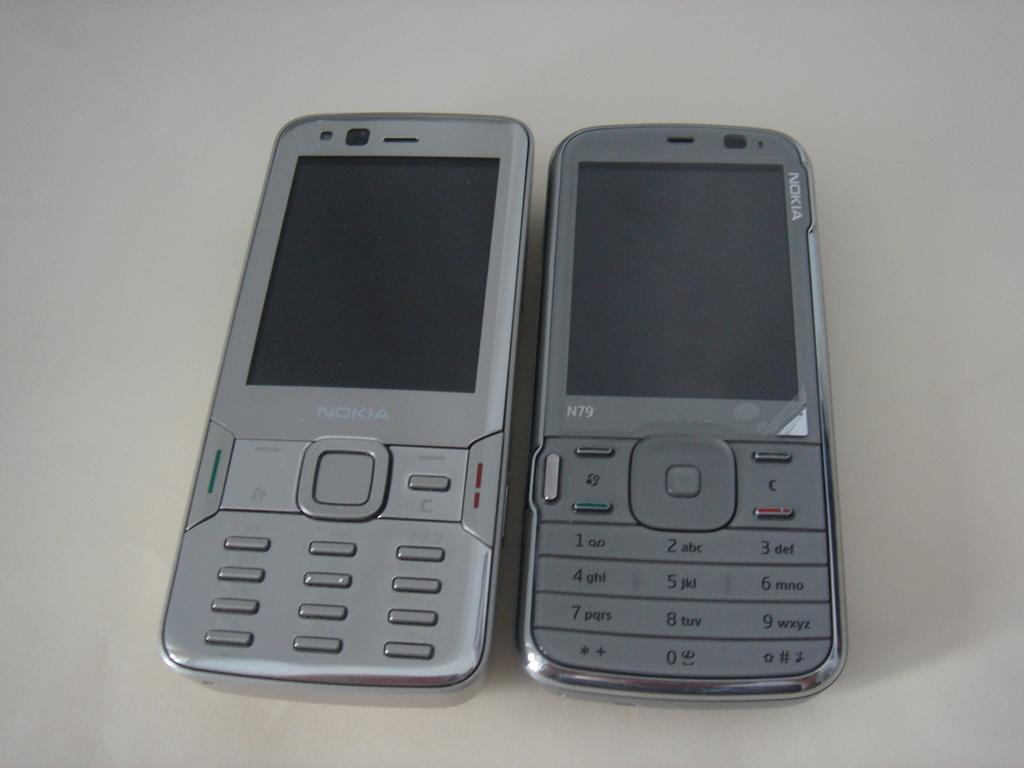<image>
Provide a brief description of the given image. an open silver phone turned off and made by Nokia 